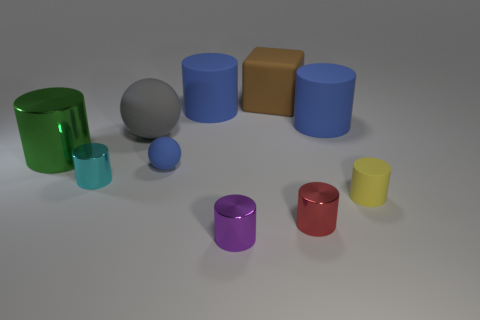Is there anything else that has the same shape as the large brown rubber thing?
Offer a terse response. No. There is a tiny rubber object behind the yellow rubber thing; is it the same shape as the tiny metal object that is behind the yellow cylinder?
Offer a very short reply. No. Do the purple object and the large brown thing have the same material?
Your answer should be compact. No. There is a shiny cylinder to the left of the small metal cylinder that is behind the matte cylinder that is in front of the large shiny cylinder; what is its size?
Your answer should be very brief. Large. What number of other things are there of the same color as the big shiny cylinder?
Offer a terse response. 0. The red object that is the same size as the purple object is what shape?
Ensure brevity in your answer.  Cylinder. How many tiny objects are brown shiny cylinders or red things?
Ensure brevity in your answer.  1. There is a small shiny cylinder behind the matte cylinder that is in front of the big gray matte sphere; is there a green thing behind it?
Provide a short and direct response. Yes. Is there a brown block of the same size as the gray rubber object?
Offer a very short reply. Yes. What is the material of the blue thing that is the same size as the yellow matte thing?
Your response must be concise. Rubber. 